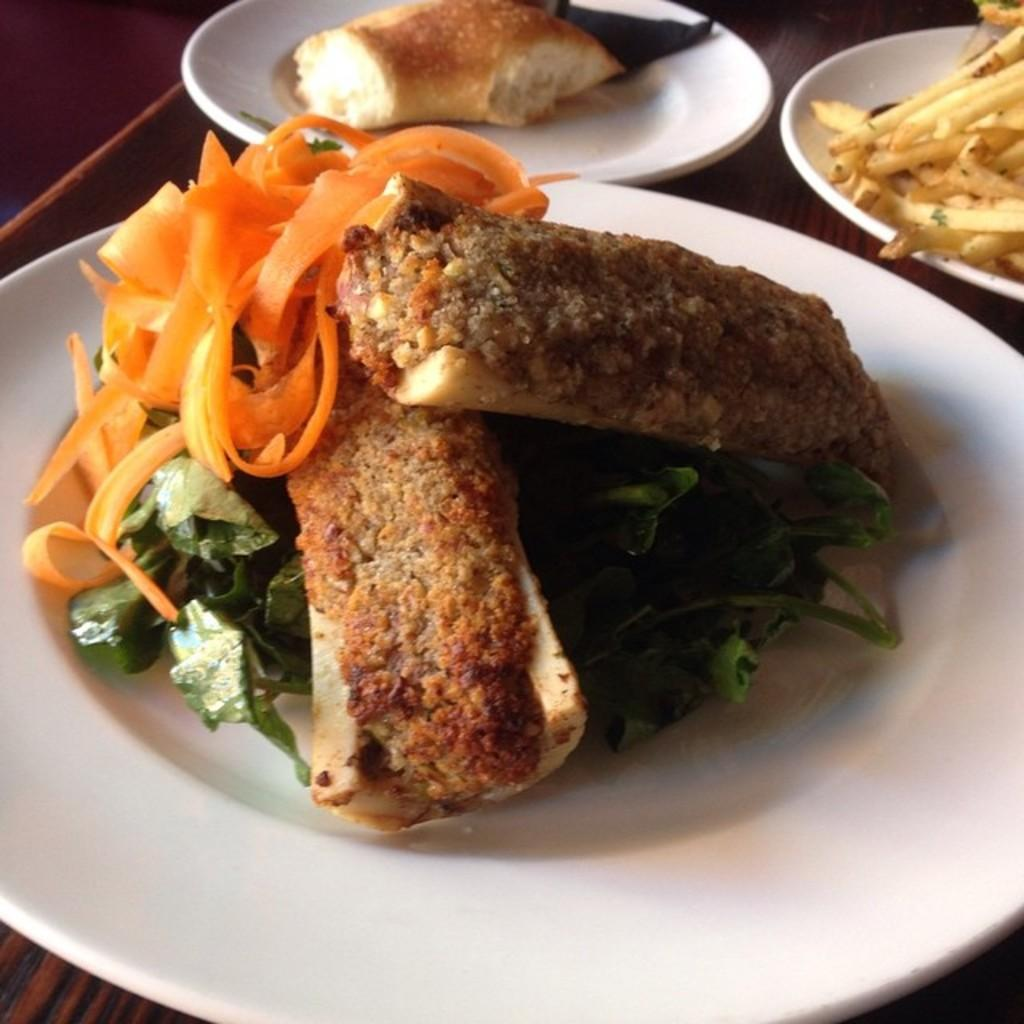What can be seen in the image related to food? There are food items in the image. How are the food items arranged or presented? The food items are placed on three plates. What type of pencil is being used to draw on the boy's trail in the image? There is no pencil, boy, or trail present in the image. 